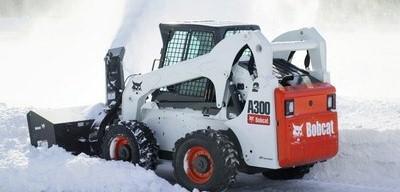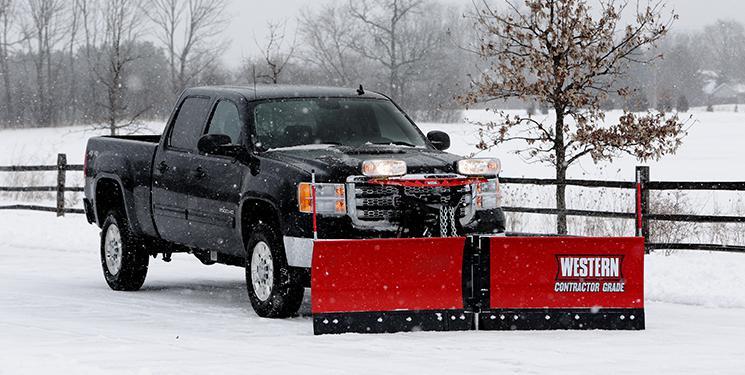The first image is the image on the left, the second image is the image on the right. Assess this claim about the two images: "The left image shows exactly one commercial snowplow truck facing the camera.". Correct or not? Answer yes or no. No. The first image is the image on the left, the second image is the image on the right. Considering the images on both sides, is "There are flags on the plow blade in the image on the left." valid? Answer yes or no. No. 